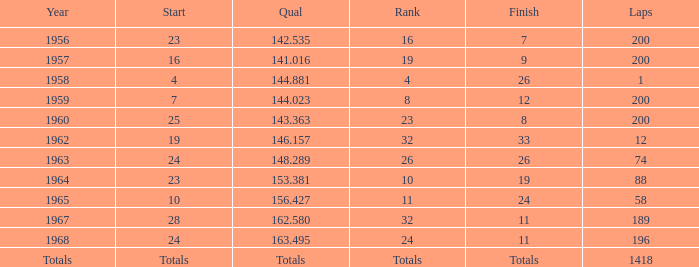Which qual also has a finish total of 9? 141.016. 